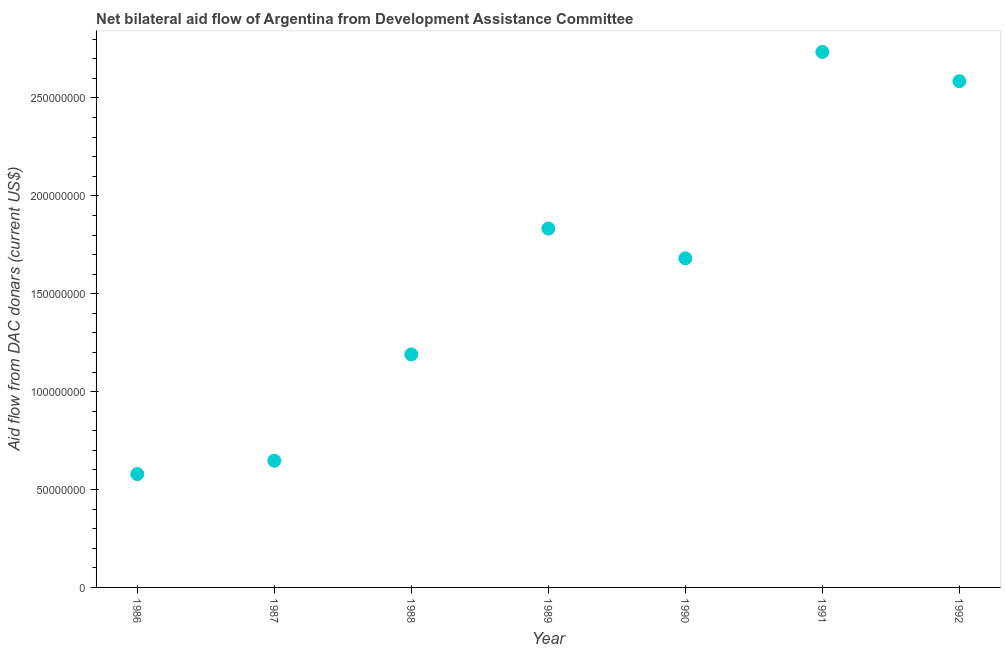What is the net bilateral aid flows from dac donors in 1991?
Make the answer very short. 2.74e+08. Across all years, what is the maximum net bilateral aid flows from dac donors?
Offer a very short reply. 2.74e+08. Across all years, what is the minimum net bilateral aid flows from dac donors?
Your answer should be very brief. 5.79e+07. In which year was the net bilateral aid flows from dac donors maximum?
Provide a short and direct response. 1991. In which year was the net bilateral aid flows from dac donors minimum?
Make the answer very short. 1986. What is the sum of the net bilateral aid flows from dac donors?
Your response must be concise. 1.13e+09. What is the difference between the net bilateral aid flows from dac donors in 1990 and 1992?
Your answer should be very brief. -9.05e+07. What is the average net bilateral aid flows from dac donors per year?
Make the answer very short. 1.61e+08. What is the median net bilateral aid flows from dac donors?
Your answer should be compact. 1.68e+08. In how many years, is the net bilateral aid flows from dac donors greater than 160000000 US$?
Provide a succinct answer. 4. Do a majority of the years between 1991 and 1990 (inclusive) have net bilateral aid flows from dac donors greater than 100000000 US$?
Make the answer very short. No. What is the ratio of the net bilateral aid flows from dac donors in 1989 to that in 1992?
Provide a succinct answer. 0.71. Is the difference between the net bilateral aid flows from dac donors in 1989 and 1991 greater than the difference between any two years?
Keep it short and to the point. No. What is the difference between the highest and the second highest net bilateral aid flows from dac donors?
Provide a short and direct response. 1.49e+07. Is the sum of the net bilateral aid flows from dac donors in 1986 and 1989 greater than the maximum net bilateral aid flows from dac donors across all years?
Make the answer very short. No. What is the difference between the highest and the lowest net bilateral aid flows from dac donors?
Keep it short and to the point. 2.16e+08. In how many years, is the net bilateral aid flows from dac donors greater than the average net bilateral aid flows from dac donors taken over all years?
Provide a succinct answer. 4. Does the net bilateral aid flows from dac donors monotonically increase over the years?
Your answer should be very brief. No. Are the values on the major ticks of Y-axis written in scientific E-notation?
Give a very brief answer. No. Does the graph contain grids?
Offer a very short reply. No. What is the title of the graph?
Your response must be concise. Net bilateral aid flow of Argentina from Development Assistance Committee. What is the label or title of the X-axis?
Keep it short and to the point. Year. What is the label or title of the Y-axis?
Offer a terse response. Aid flow from DAC donars (current US$). What is the Aid flow from DAC donars (current US$) in 1986?
Your answer should be compact. 5.79e+07. What is the Aid flow from DAC donars (current US$) in 1987?
Your response must be concise. 6.47e+07. What is the Aid flow from DAC donars (current US$) in 1988?
Your answer should be compact. 1.19e+08. What is the Aid flow from DAC donars (current US$) in 1989?
Make the answer very short. 1.83e+08. What is the Aid flow from DAC donars (current US$) in 1990?
Provide a succinct answer. 1.68e+08. What is the Aid flow from DAC donars (current US$) in 1991?
Provide a short and direct response. 2.74e+08. What is the Aid flow from DAC donars (current US$) in 1992?
Provide a succinct answer. 2.59e+08. What is the difference between the Aid flow from DAC donars (current US$) in 1986 and 1987?
Give a very brief answer. -6.85e+06. What is the difference between the Aid flow from DAC donars (current US$) in 1986 and 1988?
Make the answer very short. -6.11e+07. What is the difference between the Aid flow from DAC donars (current US$) in 1986 and 1989?
Provide a short and direct response. -1.25e+08. What is the difference between the Aid flow from DAC donars (current US$) in 1986 and 1990?
Make the answer very short. -1.10e+08. What is the difference between the Aid flow from DAC donars (current US$) in 1986 and 1991?
Offer a terse response. -2.16e+08. What is the difference between the Aid flow from DAC donars (current US$) in 1986 and 1992?
Provide a short and direct response. -2.01e+08. What is the difference between the Aid flow from DAC donars (current US$) in 1987 and 1988?
Your response must be concise. -5.43e+07. What is the difference between the Aid flow from DAC donars (current US$) in 1987 and 1989?
Offer a very short reply. -1.19e+08. What is the difference between the Aid flow from DAC donars (current US$) in 1987 and 1990?
Make the answer very short. -1.03e+08. What is the difference between the Aid flow from DAC donars (current US$) in 1987 and 1991?
Provide a succinct answer. -2.09e+08. What is the difference between the Aid flow from DAC donars (current US$) in 1987 and 1992?
Provide a succinct answer. -1.94e+08. What is the difference between the Aid flow from DAC donars (current US$) in 1988 and 1989?
Give a very brief answer. -6.43e+07. What is the difference between the Aid flow from DAC donars (current US$) in 1988 and 1990?
Your answer should be very brief. -4.91e+07. What is the difference between the Aid flow from DAC donars (current US$) in 1988 and 1991?
Provide a short and direct response. -1.55e+08. What is the difference between the Aid flow from DAC donars (current US$) in 1988 and 1992?
Your answer should be compact. -1.40e+08. What is the difference between the Aid flow from DAC donars (current US$) in 1989 and 1990?
Make the answer very short. 1.52e+07. What is the difference between the Aid flow from DAC donars (current US$) in 1989 and 1991?
Make the answer very short. -9.02e+07. What is the difference between the Aid flow from DAC donars (current US$) in 1989 and 1992?
Make the answer very short. -7.53e+07. What is the difference between the Aid flow from DAC donars (current US$) in 1990 and 1991?
Offer a terse response. -1.05e+08. What is the difference between the Aid flow from DAC donars (current US$) in 1990 and 1992?
Offer a very short reply. -9.05e+07. What is the difference between the Aid flow from DAC donars (current US$) in 1991 and 1992?
Your response must be concise. 1.49e+07. What is the ratio of the Aid flow from DAC donars (current US$) in 1986 to that in 1987?
Provide a succinct answer. 0.89. What is the ratio of the Aid flow from DAC donars (current US$) in 1986 to that in 1988?
Make the answer very short. 0.49. What is the ratio of the Aid flow from DAC donars (current US$) in 1986 to that in 1989?
Keep it short and to the point. 0.32. What is the ratio of the Aid flow from DAC donars (current US$) in 1986 to that in 1990?
Keep it short and to the point. 0.34. What is the ratio of the Aid flow from DAC donars (current US$) in 1986 to that in 1991?
Your answer should be compact. 0.21. What is the ratio of the Aid flow from DAC donars (current US$) in 1986 to that in 1992?
Provide a short and direct response. 0.22. What is the ratio of the Aid flow from DAC donars (current US$) in 1987 to that in 1988?
Your answer should be compact. 0.54. What is the ratio of the Aid flow from DAC donars (current US$) in 1987 to that in 1989?
Offer a terse response. 0.35. What is the ratio of the Aid flow from DAC donars (current US$) in 1987 to that in 1990?
Offer a terse response. 0.39. What is the ratio of the Aid flow from DAC donars (current US$) in 1987 to that in 1991?
Make the answer very short. 0.24. What is the ratio of the Aid flow from DAC donars (current US$) in 1987 to that in 1992?
Offer a terse response. 0.25. What is the ratio of the Aid flow from DAC donars (current US$) in 1988 to that in 1989?
Your response must be concise. 0.65. What is the ratio of the Aid flow from DAC donars (current US$) in 1988 to that in 1990?
Give a very brief answer. 0.71. What is the ratio of the Aid flow from DAC donars (current US$) in 1988 to that in 1991?
Give a very brief answer. 0.43. What is the ratio of the Aid flow from DAC donars (current US$) in 1988 to that in 1992?
Ensure brevity in your answer.  0.46. What is the ratio of the Aid flow from DAC donars (current US$) in 1989 to that in 1990?
Offer a very short reply. 1.09. What is the ratio of the Aid flow from DAC donars (current US$) in 1989 to that in 1991?
Offer a terse response. 0.67. What is the ratio of the Aid flow from DAC donars (current US$) in 1989 to that in 1992?
Make the answer very short. 0.71. What is the ratio of the Aid flow from DAC donars (current US$) in 1990 to that in 1991?
Provide a short and direct response. 0.61. What is the ratio of the Aid flow from DAC donars (current US$) in 1990 to that in 1992?
Provide a succinct answer. 0.65. What is the ratio of the Aid flow from DAC donars (current US$) in 1991 to that in 1992?
Ensure brevity in your answer.  1.06. 